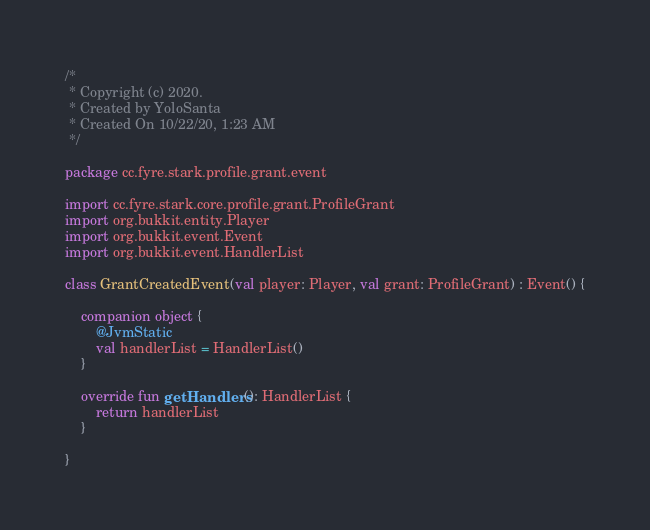Convert code to text. <code><loc_0><loc_0><loc_500><loc_500><_Kotlin_>/*
 * Copyright (c) 2020.
 * Created by YoloSanta
 * Created On 10/22/20, 1:23 AM
 */

package cc.fyre.stark.profile.grant.event

import cc.fyre.stark.core.profile.grant.ProfileGrant
import org.bukkit.entity.Player
import org.bukkit.event.Event
import org.bukkit.event.HandlerList

class GrantCreatedEvent(val player: Player, val grant: ProfileGrant) : Event() {

    companion object {
        @JvmStatic
        val handlerList = HandlerList()
    }

    override fun getHandlers(): HandlerList {
        return handlerList
    }

}</code> 